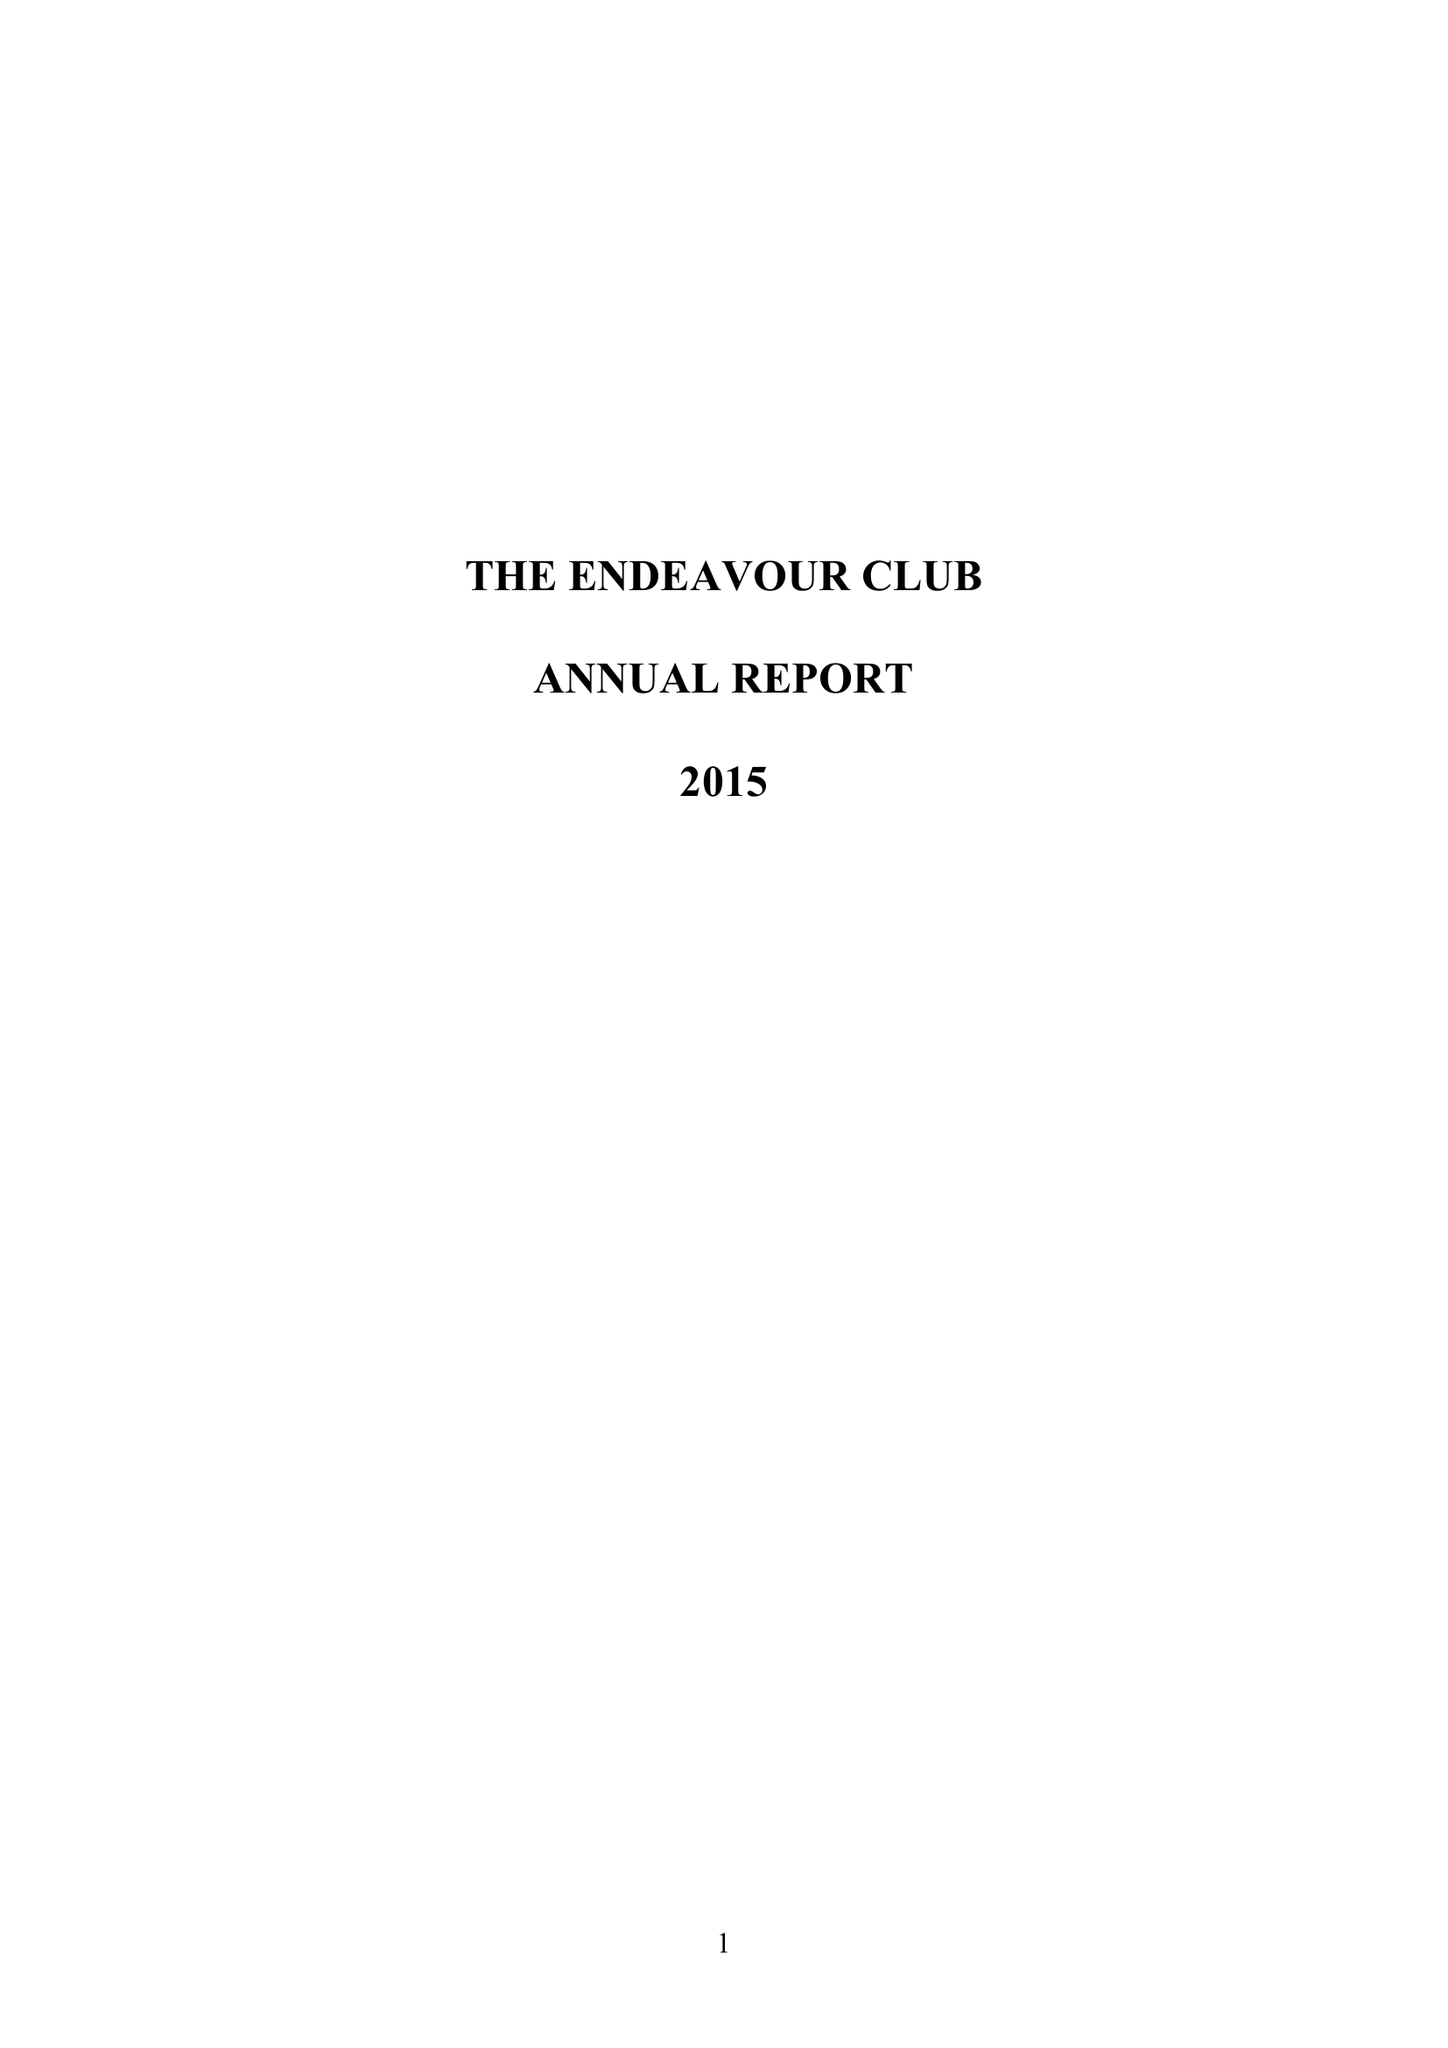What is the value for the charity_name?
Answer the question using a single word or phrase. The Endeavour Club 